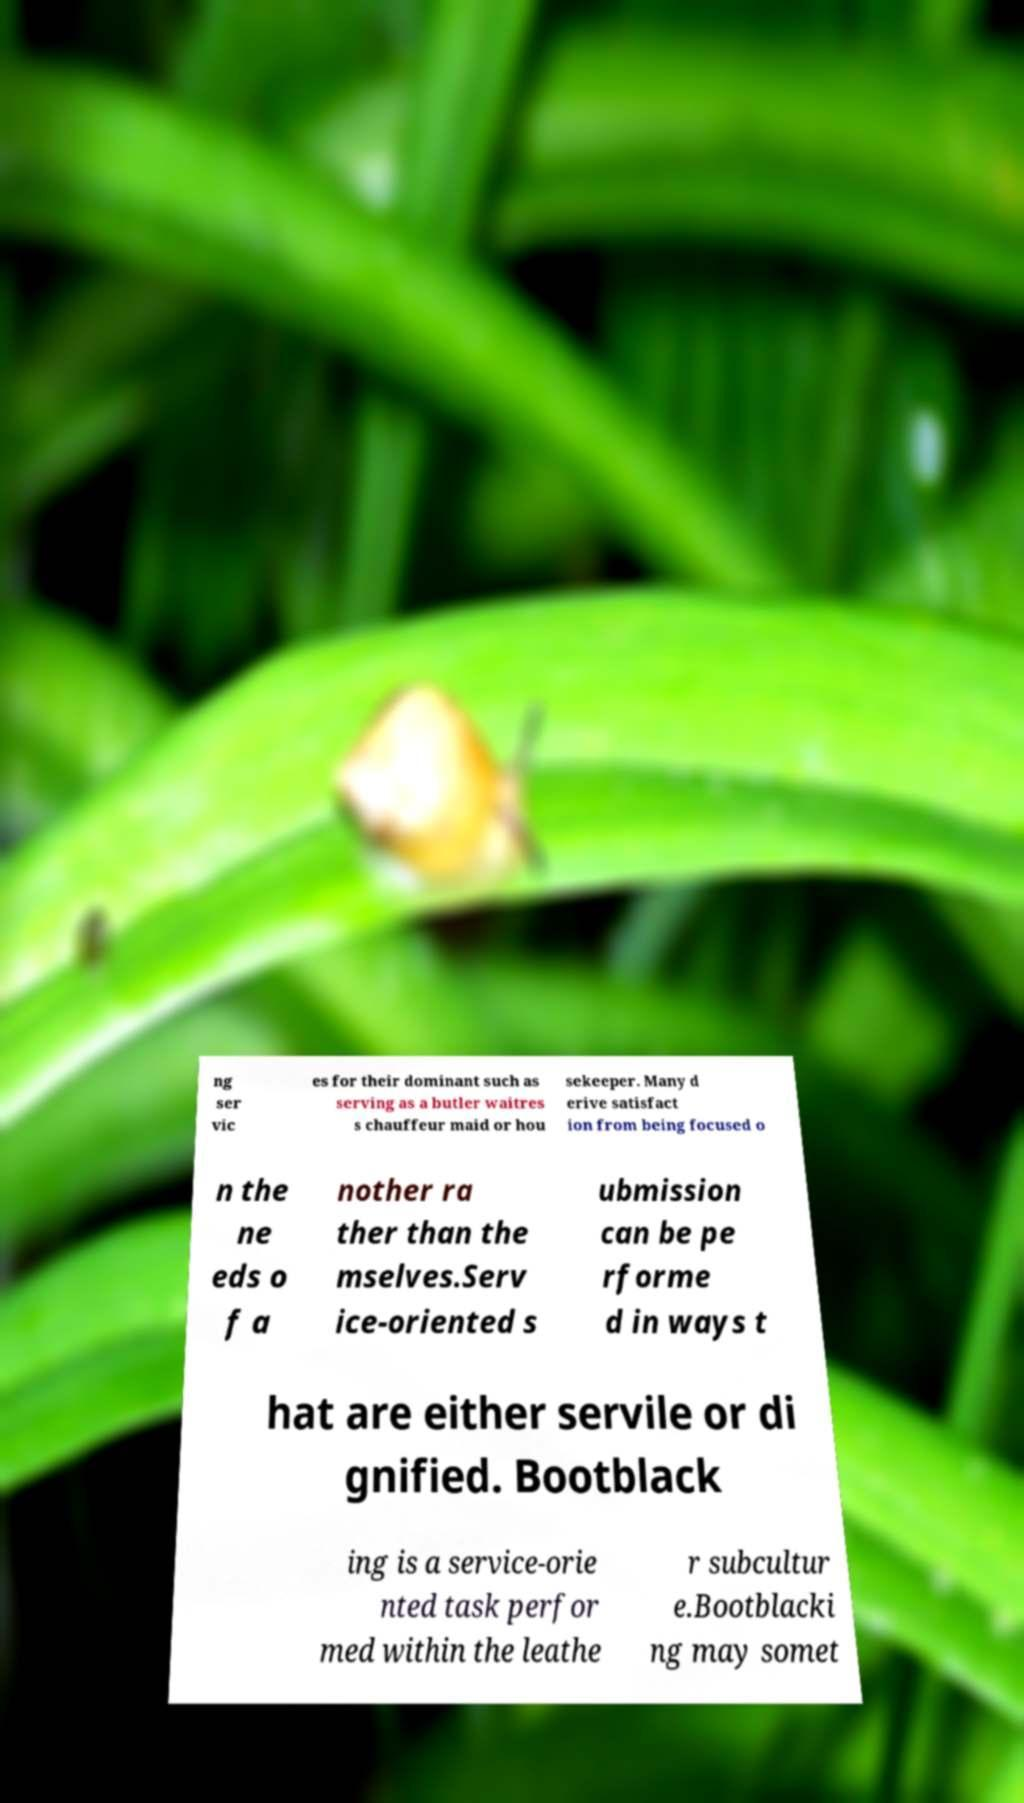Please identify and transcribe the text found in this image. ng ser vic es for their dominant such as serving as a butler waitres s chauffeur maid or hou sekeeper. Many d erive satisfact ion from being focused o n the ne eds o f a nother ra ther than the mselves.Serv ice-oriented s ubmission can be pe rforme d in ways t hat are either servile or di gnified. Bootblack ing is a service-orie nted task perfor med within the leathe r subcultur e.Bootblacki ng may somet 